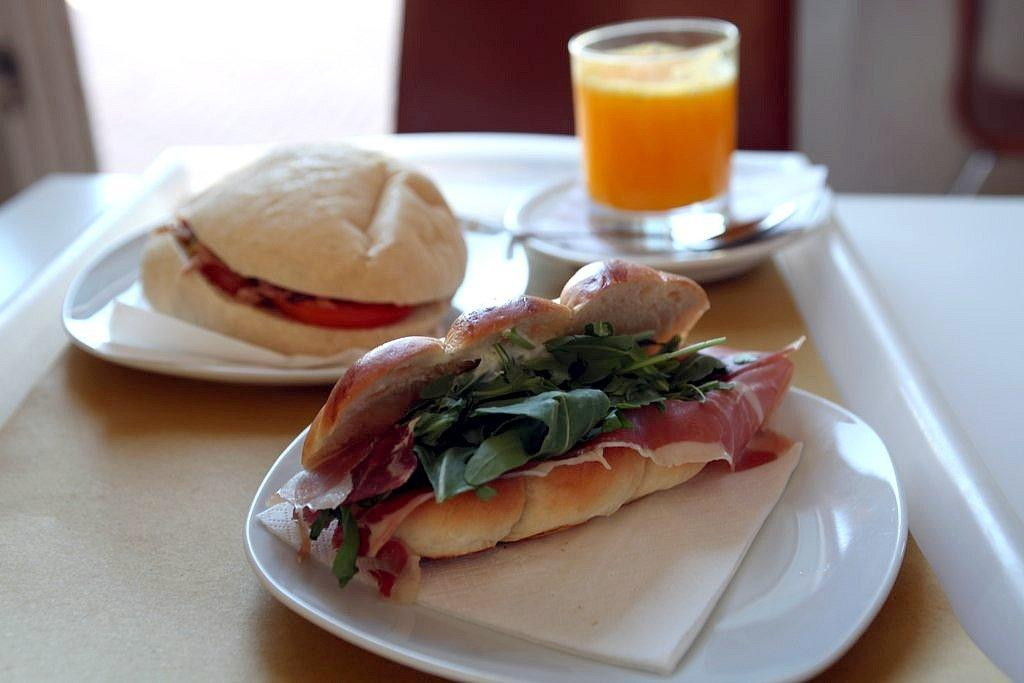What type of food or snacks can be seen in the image? There are eatables in the image. What type of beverage is in the glass in the image? There is a glass of drink in the image. What color is the plate that is visible in the image? There is a white plate in the image. Where is the white plate located in the image? The white plate is on a table. What type of muscle is visible in the image? There is no muscle visible in the image; it features eatables, a glass of drink, and a white plate on a table. 